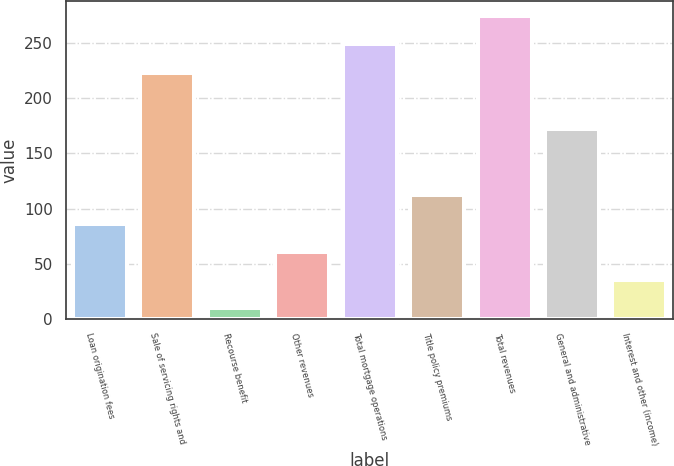Convert chart. <chart><loc_0><loc_0><loc_500><loc_500><bar_chart><fcel>Loan origination fees<fcel>Sale of servicing rights and<fcel>Recourse benefit<fcel>Other revenues<fcel>Total mortgage operations<fcel>Title policy premiums<fcel>Total revenues<fcel>General and administrative<fcel>Interest and other (income)<nl><fcel>86.36<fcel>223.44<fcel>9.8<fcel>60.84<fcel>248.96<fcel>111.88<fcel>274.48<fcel>172.4<fcel>35.32<nl></chart> 